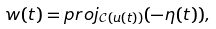Convert formula to latex. <formula><loc_0><loc_0><loc_500><loc_500>w ( t ) = p r o j _ { \mathcal { C } ( u ( t ) ) } ( - \eta ( t ) ) ,</formula> 